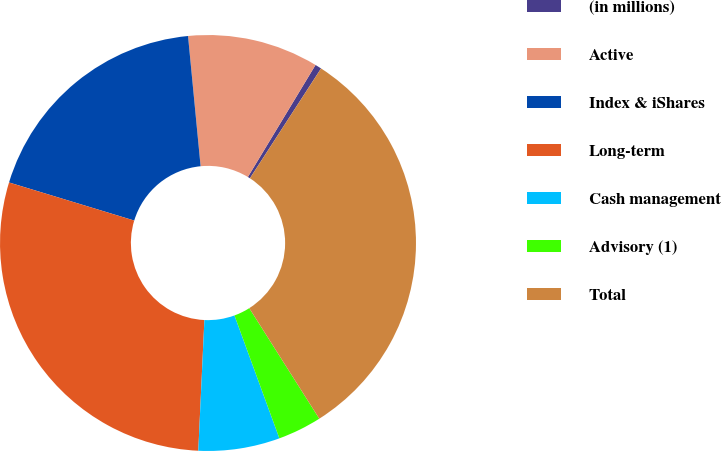Convert chart to OTSL. <chart><loc_0><loc_0><loc_500><loc_500><pie_chart><fcel>(in millions)<fcel>Active<fcel>Index & iShares<fcel>Long-term<fcel>Cash management<fcel>Advisory (1)<fcel>Total<nl><fcel>0.5%<fcel>10.18%<fcel>18.77%<fcel>28.96%<fcel>6.32%<fcel>3.41%<fcel>31.87%<nl></chart> 